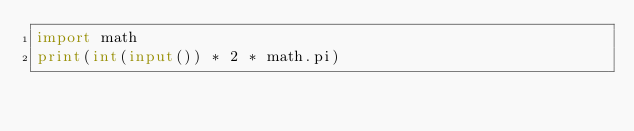<code> <loc_0><loc_0><loc_500><loc_500><_Python_>import math
print(int(input()) * 2 * math.pi)</code> 